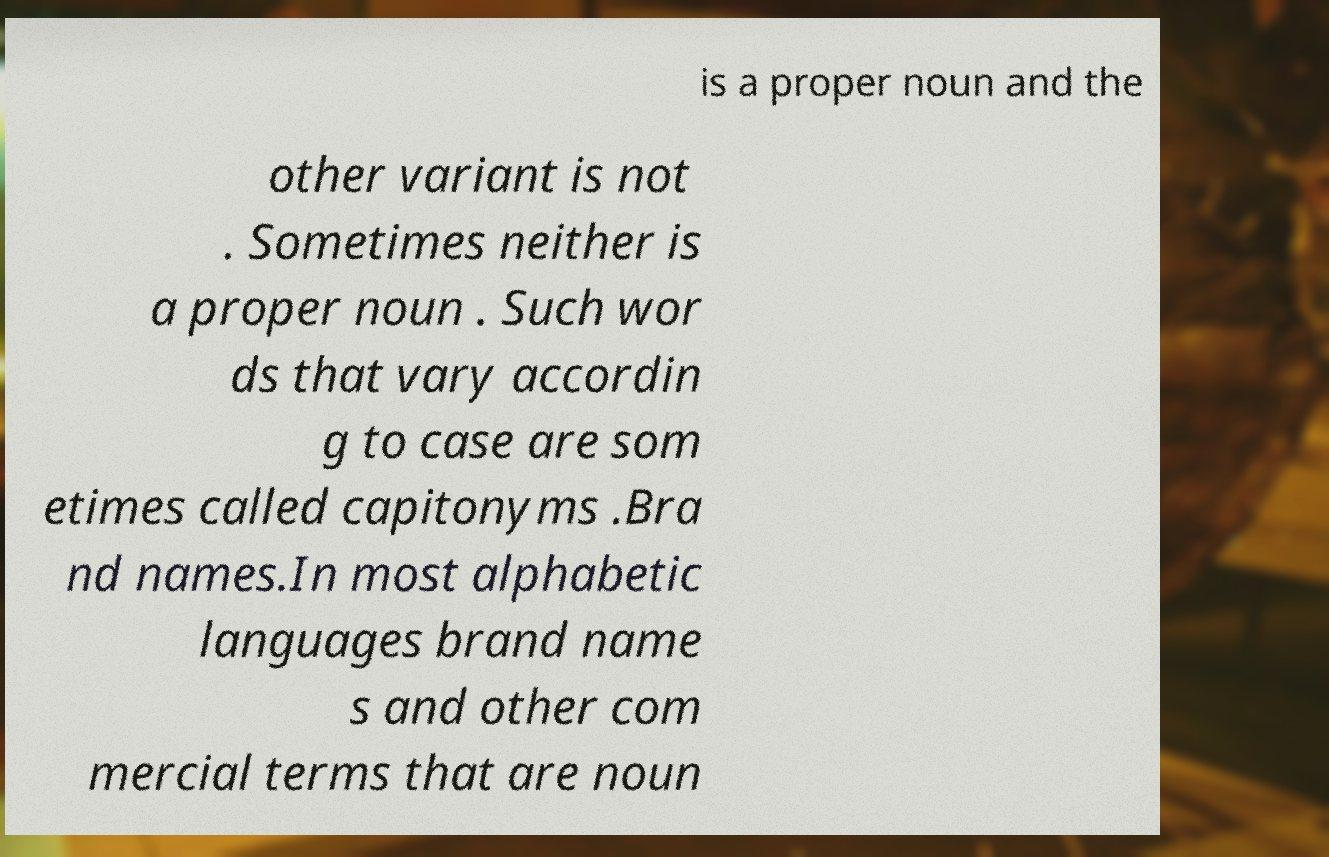Could you extract and type out the text from this image? is a proper noun and the other variant is not . Sometimes neither is a proper noun . Such wor ds that vary accordin g to case are som etimes called capitonyms .Bra nd names.In most alphabetic languages brand name s and other com mercial terms that are noun 